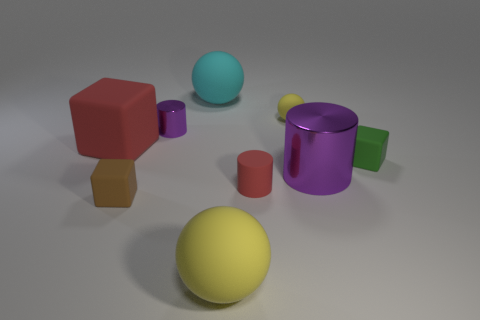Subtract 2 blocks. How many blocks are left? 1 Subtract all cyan spheres. How many spheres are left? 2 Subtract all green rubber blocks. How many blocks are left? 2 Subtract all cubes. How many objects are left? 6 Subtract 0 blue cylinders. How many objects are left? 9 Subtract all brown cylinders. Subtract all cyan balls. How many cylinders are left? 3 Subtract all gray cubes. How many red cylinders are left? 1 Subtract all large red rubber things. Subtract all big red rubber blocks. How many objects are left? 7 Add 7 tiny green blocks. How many tiny green blocks are left? 8 Add 2 red shiny objects. How many red shiny objects exist? 2 